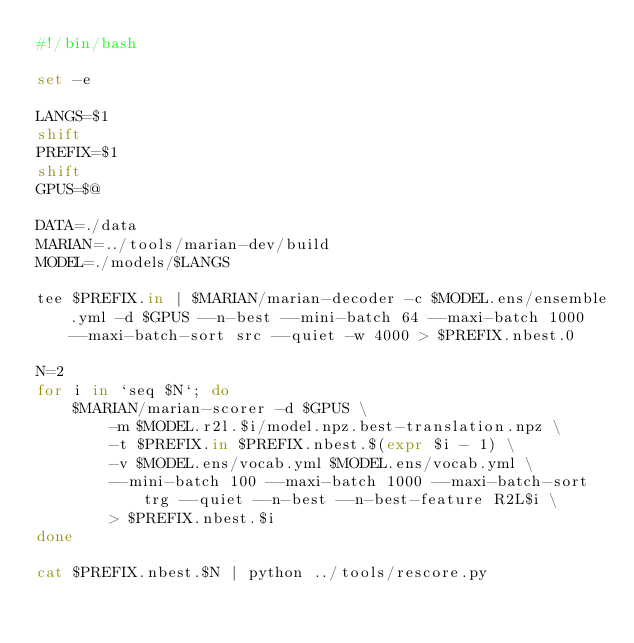Convert code to text. <code><loc_0><loc_0><loc_500><loc_500><_Bash_>#!/bin/bash

set -e

LANGS=$1
shift
PREFIX=$1
shift
GPUS=$@

DATA=./data
MARIAN=../tools/marian-dev/build
MODEL=./models/$LANGS

tee $PREFIX.in | $MARIAN/marian-decoder -c $MODEL.ens/ensemble.yml -d $GPUS --n-best --mini-batch 64 --maxi-batch 1000 --maxi-batch-sort src --quiet -w 4000 > $PREFIX.nbest.0

N=2
for i in `seq $N`; do
    $MARIAN/marian-scorer -d $GPUS \
        -m $MODEL.r2l.$i/model.npz.best-translation.npz \
        -t $PREFIX.in $PREFIX.nbest.$(expr $i - 1) \
        -v $MODEL.ens/vocab.yml $MODEL.ens/vocab.yml \
        --mini-batch 100 --maxi-batch 1000 --maxi-batch-sort trg --quiet --n-best --n-best-feature R2L$i \
        > $PREFIX.nbest.$i
done

cat $PREFIX.nbest.$N | python ../tools/rescore.py
</code> 